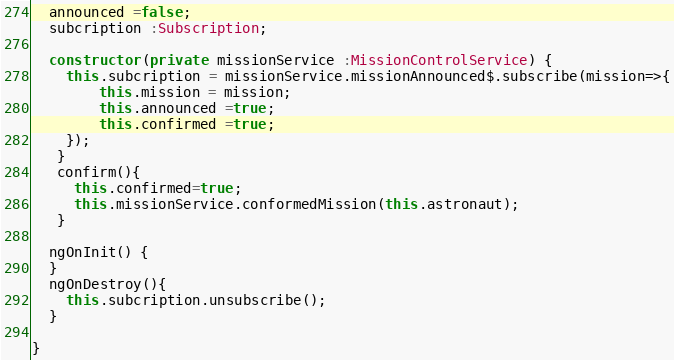Convert code to text. <code><loc_0><loc_0><loc_500><loc_500><_TypeScript_>  announced =false;
  subcription :Subscription;

  constructor(private missionService :MissionControlService) {
    this.subcription = missionService.missionAnnounced$.subscribe(mission=>{
      	this.mission = mission;
        this.announced =true;
        this.confirmed =true; 
    });
   }
   confirm(){
     this.confirmed=true;
     this.missionService.conformedMission(this.astronaut);
   }

  ngOnInit() {
  }
  ngOnDestroy(){
    this.subcription.unsubscribe();
  }

}
</code> 